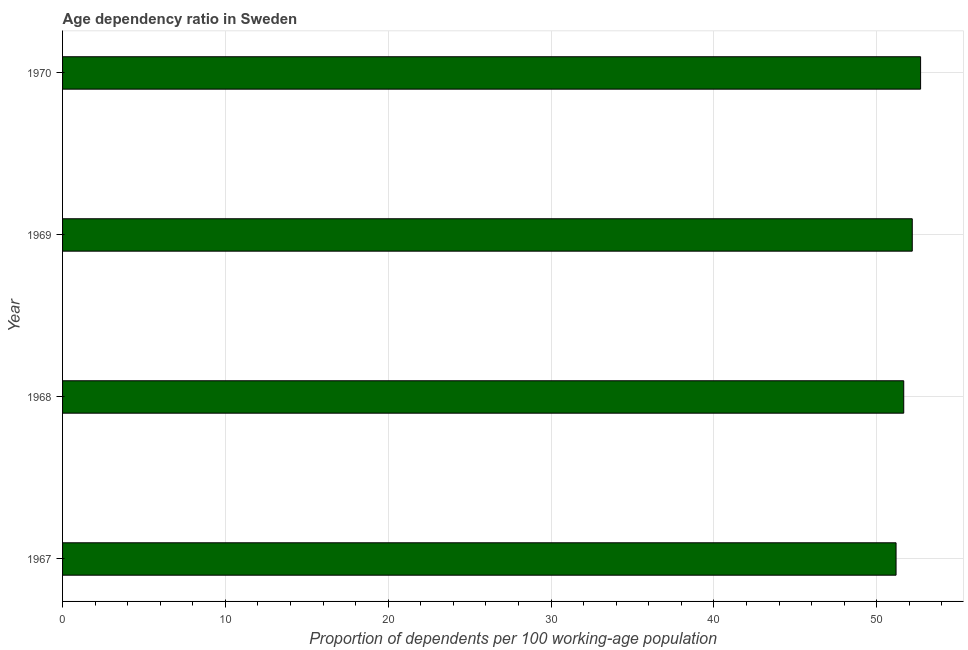What is the title of the graph?
Ensure brevity in your answer.  Age dependency ratio in Sweden. What is the label or title of the X-axis?
Make the answer very short. Proportion of dependents per 100 working-age population. What is the age dependency ratio in 1970?
Your response must be concise. 52.69. Across all years, what is the maximum age dependency ratio?
Your answer should be very brief. 52.69. Across all years, what is the minimum age dependency ratio?
Your response must be concise. 51.18. In which year was the age dependency ratio minimum?
Make the answer very short. 1967. What is the sum of the age dependency ratio?
Ensure brevity in your answer.  207.69. What is the difference between the age dependency ratio in 1968 and 1970?
Offer a very short reply. -1.03. What is the average age dependency ratio per year?
Give a very brief answer. 51.92. What is the median age dependency ratio?
Offer a very short reply. 51.91. Do a majority of the years between 1967 and 1968 (inclusive) have age dependency ratio greater than 10 ?
Offer a terse response. Yes. What is the ratio of the age dependency ratio in 1969 to that in 1970?
Your answer should be compact. 0.99. Is the difference between the age dependency ratio in 1967 and 1969 greater than the difference between any two years?
Ensure brevity in your answer.  No. What is the difference between the highest and the second highest age dependency ratio?
Provide a succinct answer. 0.51. What is the difference between the highest and the lowest age dependency ratio?
Give a very brief answer. 1.51. Are all the bars in the graph horizontal?
Keep it short and to the point. Yes. How many years are there in the graph?
Your answer should be compact. 4. What is the Proportion of dependents per 100 working-age population of 1967?
Your response must be concise. 51.18. What is the Proportion of dependents per 100 working-age population of 1968?
Offer a very short reply. 51.65. What is the Proportion of dependents per 100 working-age population in 1969?
Your response must be concise. 52.18. What is the Proportion of dependents per 100 working-age population in 1970?
Provide a short and direct response. 52.69. What is the difference between the Proportion of dependents per 100 working-age population in 1967 and 1968?
Ensure brevity in your answer.  -0.47. What is the difference between the Proportion of dependents per 100 working-age population in 1967 and 1969?
Your response must be concise. -1. What is the difference between the Proportion of dependents per 100 working-age population in 1967 and 1970?
Keep it short and to the point. -1.51. What is the difference between the Proportion of dependents per 100 working-age population in 1968 and 1969?
Make the answer very short. -0.52. What is the difference between the Proportion of dependents per 100 working-age population in 1968 and 1970?
Your answer should be compact. -1.03. What is the difference between the Proportion of dependents per 100 working-age population in 1969 and 1970?
Your answer should be very brief. -0.51. What is the ratio of the Proportion of dependents per 100 working-age population in 1967 to that in 1969?
Provide a short and direct response. 0.98. What is the ratio of the Proportion of dependents per 100 working-age population in 1968 to that in 1970?
Keep it short and to the point. 0.98. 